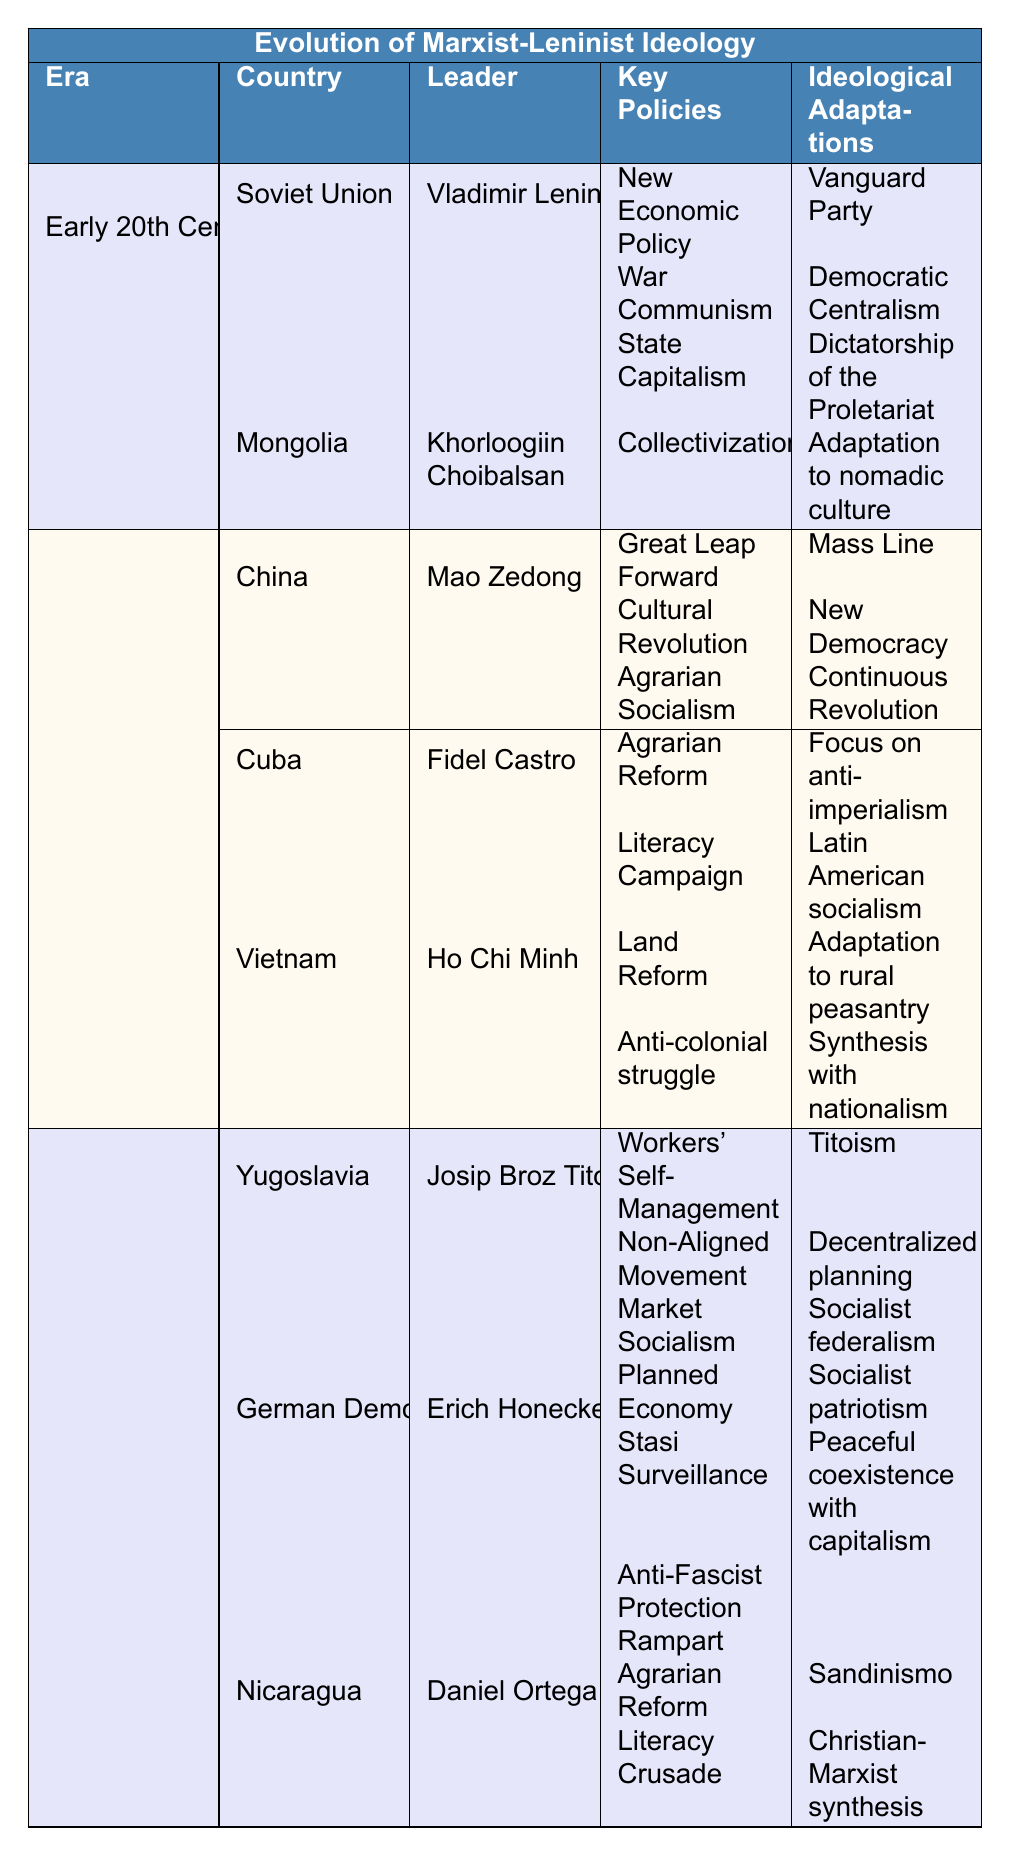What were the key policies of the Soviet Union under Lenin? The table lists three key policies for the Soviet Union under Vladimir Lenin: New Economic Policy, War Communism, and State Capitalism. These are directly stated in the relevant section of the table.
Answer: New Economic Policy, War Communism, State Capitalism Which leader is associated with the key policy of Agrarian Reform in Cuba? The table shows that Fidel Castro is the leader associated with the key policy of Agrarian Reform in Cuba. This is found under the Cuba entry in the Mid 20th Century section.
Answer: Fidel Castro Did Mongolia adopt Soviet-style centralization? According to the table, one of Mongolia's ideological adaptations under Khorloogiin Choibalsan was indeed "Soviet-style centralization." The table explicitly states this adaptation.
Answer: Yes What ideological adaptations were associated with the Great Leap Forward in China? The table indicates that the ideological adaptations associated with the Great Leap Forward were Mass Line, New Democracy, and Continuous Revolution, as they appear in the section under China.
Answer: Mass Line, New Democracy, Continuous Revolution How many leaders are listed for the Late 20th Century? The Late 20th Century section of the table lists three leaders: Josip Broz Tito (Yugoslavia), Erich Honecker (German Democratic Republic), and Daniel Ortega (Nicaragua). Counting them gives a total of three leaders.
Answer: 3 What key policy did Dani Ortega's regime in Nicaragua share with Fidel Castro's regime in Cuba? Both regimes share "Agrarian Reform" as a key policy. This can be verified by looking at the relevant entries for each country in the table under the respective eras.
Answer: Agrarian Reform Which country under Mao Zedong emphasized adaptation to rural peasantry? The table states that Vietnam, under Ho Chi Minh, emphasized "Adaptation to rural peasantry." While Mao Zedong led China, the adaptation mentioned here specifically pertains to Vietnam.
Answer: Vietnam Compare the ideological adaptations of Yugoslavia under Tito and the German Democratic Republic under Honecker. The table lists Tito's ideological adaptations as Titoism, Decentralized planning, and Socialist federalism, whereas Honecker's adaptations include Socialist patriotism and Peaceful coexistence with capitalism. This requires identifying these adaptations from their respective sections in the table.
Answer: Titoism, Decentralized planning, Socialist federalism; Socialist patriotism, Peaceful coexistence with capitalism Which regime had a focus on anti-imperialism and who was its leader? The Cuban regime under Fidel Castro had a focus on anti-imperialism according to the ideological adaptations listed in the table. The leader is Fidel Castro, as stated under the Cuba entry.
Answer: Cuba; Fidel Castro What was a significant adaptation made by Mongolia in the Early 20th Century? A significant adaptation made by Mongolia in the Early 20th Century was "Adaptation to nomadic culture," as represented in the table under Mongolia's ideological adaptations.
Answer: Adaptation to nomadic culture What common key policy did both Yugoslavia and Nicaragua share? The table does not show any shared key policy between Yugoslavia and Nicaragua. The key policies listed for Yugoslavia (Workers' Self-Management, Non-Aligned Movement, Market Socialism) differ from those for Nicaragua (Agrarian Reform, Literacy Crusade, Mixed Economy). Thus, there is no commonality in their key policies.
Answer: None 